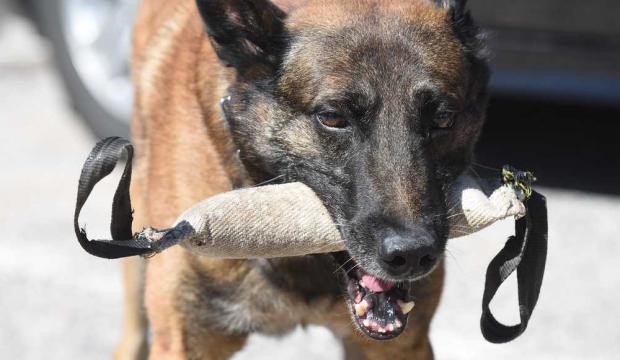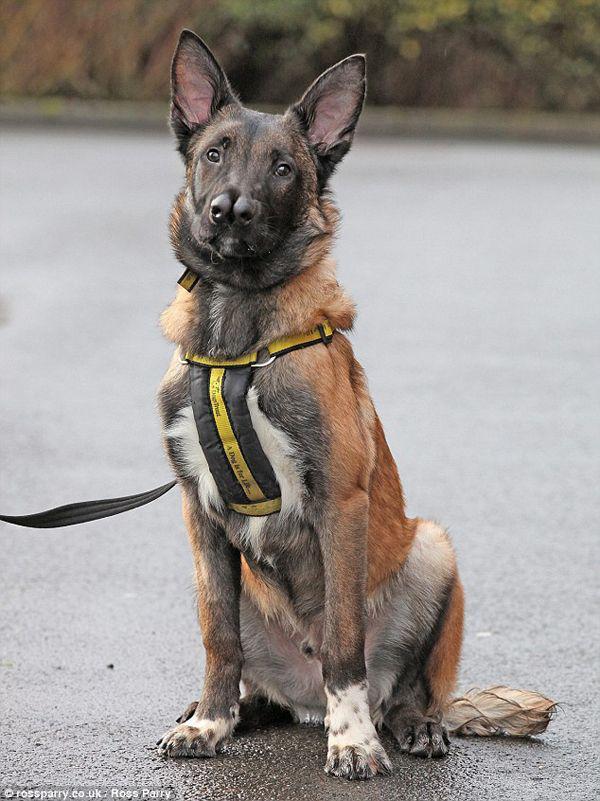The first image is the image on the left, the second image is the image on the right. Assess this claim about the two images: "No human is visible next to the german shepherd dog in the right image.". Correct or not? Answer yes or no. Yes. The first image is the image on the left, the second image is the image on the right. For the images shown, is this caption "A dog is lying on the cement in one of the images." true? Answer yes or no. No. 